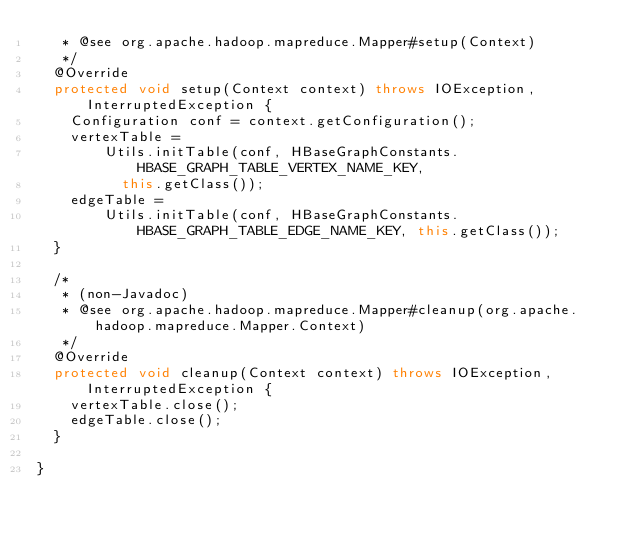<code> <loc_0><loc_0><loc_500><loc_500><_Java_>   * @see org.apache.hadoop.mapreduce.Mapper#setup(Context)
   */
  @Override
  protected void setup(Context context) throws IOException, InterruptedException {
    Configuration conf = context.getConfiguration();
    vertexTable =
        Utils.initTable(conf, HBaseGraphConstants.HBASE_GRAPH_TABLE_VERTEX_NAME_KEY,
          this.getClass());
    edgeTable =
        Utils.initTable(conf, HBaseGraphConstants.HBASE_GRAPH_TABLE_EDGE_NAME_KEY, this.getClass());
  }

  /*
   * (non-Javadoc)
   * @see org.apache.hadoop.mapreduce.Mapper#cleanup(org.apache.hadoop.mapreduce.Mapper.Context)
   */
  @Override
  protected void cleanup(Context context) throws IOException, InterruptedException {
    vertexTable.close();
    edgeTable.close();
  }

}
</code> 